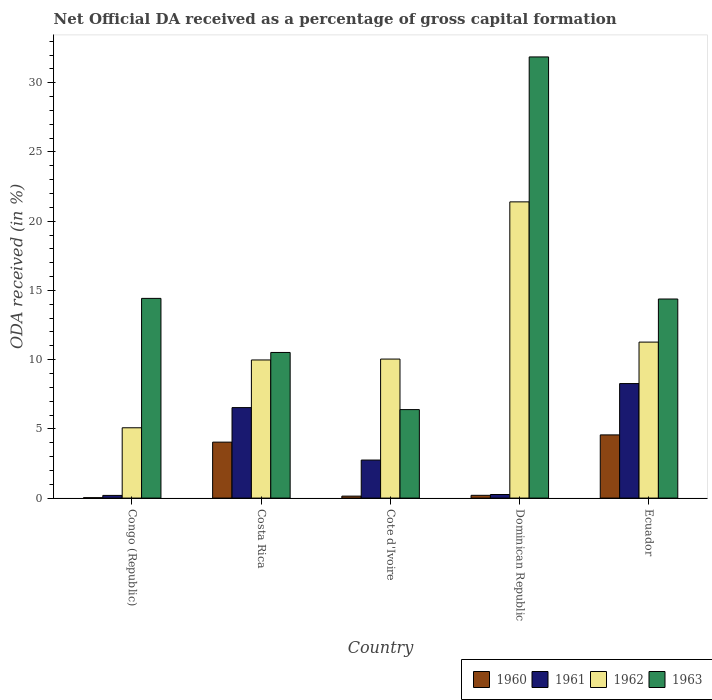How many different coloured bars are there?
Your answer should be compact. 4. How many groups of bars are there?
Your answer should be very brief. 5. How many bars are there on the 1st tick from the left?
Keep it short and to the point. 4. How many bars are there on the 3rd tick from the right?
Provide a short and direct response. 4. What is the label of the 3rd group of bars from the left?
Provide a short and direct response. Cote d'Ivoire. What is the net ODA received in 1962 in Dominican Republic?
Ensure brevity in your answer.  21.4. Across all countries, what is the maximum net ODA received in 1960?
Provide a short and direct response. 4.56. Across all countries, what is the minimum net ODA received in 1962?
Offer a very short reply. 5.08. In which country was the net ODA received in 1961 maximum?
Ensure brevity in your answer.  Ecuador. In which country was the net ODA received in 1960 minimum?
Your response must be concise. Congo (Republic). What is the total net ODA received in 1961 in the graph?
Keep it short and to the point. 18.01. What is the difference between the net ODA received in 1962 in Congo (Republic) and that in Ecuador?
Provide a short and direct response. -6.19. What is the difference between the net ODA received in 1963 in Costa Rica and the net ODA received in 1961 in Ecuador?
Provide a succinct answer. 2.25. What is the average net ODA received in 1961 per country?
Provide a succinct answer. 3.6. What is the difference between the net ODA received of/in 1962 and net ODA received of/in 1961 in Congo (Republic)?
Your response must be concise. 4.89. What is the ratio of the net ODA received in 1960 in Cote d'Ivoire to that in Dominican Republic?
Your answer should be very brief. 0.71. Is the difference between the net ODA received in 1962 in Costa Rica and Ecuador greater than the difference between the net ODA received in 1961 in Costa Rica and Ecuador?
Keep it short and to the point. Yes. What is the difference between the highest and the second highest net ODA received in 1960?
Your answer should be very brief. -4.36. What is the difference between the highest and the lowest net ODA received in 1963?
Provide a succinct answer. 25.47. Is the sum of the net ODA received in 1963 in Congo (Republic) and Ecuador greater than the maximum net ODA received in 1960 across all countries?
Give a very brief answer. Yes. Is it the case that in every country, the sum of the net ODA received in 1961 and net ODA received in 1962 is greater than the sum of net ODA received in 1963 and net ODA received in 1960?
Offer a terse response. No. What does the 2nd bar from the left in Ecuador represents?
Give a very brief answer. 1961. What does the 1st bar from the right in Costa Rica represents?
Give a very brief answer. 1963. Are all the bars in the graph horizontal?
Your answer should be very brief. No. What is the difference between two consecutive major ticks on the Y-axis?
Keep it short and to the point. 5. Does the graph contain any zero values?
Your response must be concise. No. How are the legend labels stacked?
Keep it short and to the point. Horizontal. What is the title of the graph?
Your response must be concise. Net Official DA received as a percentage of gross capital formation. Does "2014" appear as one of the legend labels in the graph?
Provide a short and direct response. No. What is the label or title of the Y-axis?
Ensure brevity in your answer.  ODA received (in %). What is the ODA received (in %) in 1960 in Congo (Republic)?
Keep it short and to the point. 0.03. What is the ODA received (in %) of 1961 in Congo (Republic)?
Give a very brief answer. 0.19. What is the ODA received (in %) of 1962 in Congo (Republic)?
Give a very brief answer. 5.08. What is the ODA received (in %) of 1963 in Congo (Republic)?
Make the answer very short. 14.43. What is the ODA received (in %) of 1960 in Costa Rica?
Make the answer very short. 4.04. What is the ODA received (in %) of 1961 in Costa Rica?
Keep it short and to the point. 6.54. What is the ODA received (in %) in 1962 in Costa Rica?
Your response must be concise. 9.98. What is the ODA received (in %) in 1963 in Costa Rica?
Keep it short and to the point. 10.52. What is the ODA received (in %) in 1960 in Cote d'Ivoire?
Offer a terse response. 0.14. What is the ODA received (in %) in 1961 in Cote d'Ivoire?
Ensure brevity in your answer.  2.75. What is the ODA received (in %) of 1962 in Cote d'Ivoire?
Your answer should be compact. 10.04. What is the ODA received (in %) of 1963 in Cote d'Ivoire?
Your answer should be compact. 6.39. What is the ODA received (in %) in 1960 in Dominican Republic?
Your answer should be very brief. 0.2. What is the ODA received (in %) in 1961 in Dominican Republic?
Give a very brief answer. 0.26. What is the ODA received (in %) of 1962 in Dominican Republic?
Give a very brief answer. 21.4. What is the ODA received (in %) of 1963 in Dominican Republic?
Your answer should be very brief. 31.86. What is the ODA received (in %) of 1960 in Ecuador?
Provide a short and direct response. 4.56. What is the ODA received (in %) in 1961 in Ecuador?
Make the answer very short. 8.27. What is the ODA received (in %) of 1962 in Ecuador?
Your answer should be compact. 11.27. What is the ODA received (in %) of 1963 in Ecuador?
Provide a succinct answer. 14.38. Across all countries, what is the maximum ODA received (in %) in 1960?
Make the answer very short. 4.56. Across all countries, what is the maximum ODA received (in %) of 1961?
Your answer should be compact. 8.27. Across all countries, what is the maximum ODA received (in %) in 1962?
Your answer should be very brief. 21.4. Across all countries, what is the maximum ODA received (in %) in 1963?
Your answer should be compact. 31.86. Across all countries, what is the minimum ODA received (in %) in 1960?
Your response must be concise. 0.03. Across all countries, what is the minimum ODA received (in %) of 1961?
Your answer should be very brief. 0.19. Across all countries, what is the minimum ODA received (in %) of 1962?
Make the answer very short. 5.08. Across all countries, what is the minimum ODA received (in %) in 1963?
Your answer should be very brief. 6.39. What is the total ODA received (in %) in 1960 in the graph?
Your answer should be compact. 8.98. What is the total ODA received (in %) in 1961 in the graph?
Provide a succinct answer. 18.01. What is the total ODA received (in %) of 1962 in the graph?
Your response must be concise. 57.76. What is the total ODA received (in %) in 1963 in the graph?
Provide a succinct answer. 77.58. What is the difference between the ODA received (in %) in 1960 in Congo (Republic) and that in Costa Rica?
Your answer should be very brief. -4.01. What is the difference between the ODA received (in %) in 1961 in Congo (Republic) and that in Costa Rica?
Make the answer very short. -6.34. What is the difference between the ODA received (in %) in 1962 in Congo (Republic) and that in Costa Rica?
Your answer should be compact. -4.9. What is the difference between the ODA received (in %) in 1963 in Congo (Republic) and that in Costa Rica?
Provide a succinct answer. 3.91. What is the difference between the ODA received (in %) of 1960 in Congo (Republic) and that in Cote d'Ivoire?
Give a very brief answer. -0.11. What is the difference between the ODA received (in %) of 1961 in Congo (Republic) and that in Cote d'Ivoire?
Ensure brevity in your answer.  -2.55. What is the difference between the ODA received (in %) in 1962 in Congo (Republic) and that in Cote d'Ivoire?
Your answer should be very brief. -4.96. What is the difference between the ODA received (in %) of 1963 in Congo (Republic) and that in Cote d'Ivoire?
Provide a short and direct response. 8.03. What is the difference between the ODA received (in %) of 1960 in Congo (Republic) and that in Dominican Republic?
Your answer should be very brief. -0.17. What is the difference between the ODA received (in %) in 1961 in Congo (Republic) and that in Dominican Republic?
Provide a short and direct response. -0.06. What is the difference between the ODA received (in %) in 1962 in Congo (Republic) and that in Dominican Republic?
Offer a very short reply. -16.32. What is the difference between the ODA received (in %) of 1963 in Congo (Republic) and that in Dominican Republic?
Make the answer very short. -17.44. What is the difference between the ODA received (in %) of 1960 in Congo (Republic) and that in Ecuador?
Your answer should be very brief. -4.54. What is the difference between the ODA received (in %) in 1961 in Congo (Republic) and that in Ecuador?
Keep it short and to the point. -8.08. What is the difference between the ODA received (in %) of 1962 in Congo (Republic) and that in Ecuador?
Your answer should be very brief. -6.19. What is the difference between the ODA received (in %) in 1963 in Congo (Republic) and that in Ecuador?
Give a very brief answer. 0.05. What is the difference between the ODA received (in %) in 1960 in Costa Rica and that in Cote d'Ivoire?
Your answer should be compact. 3.9. What is the difference between the ODA received (in %) of 1961 in Costa Rica and that in Cote d'Ivoire?
Make the answer very short. 3.79. What is the difference between the ODA received (in %) in 1962 in Costa Rica and that in Cote d'Ivoire?
Give a very brief answer. -0.06. What is the difference between the ODA received (in %) in 1963 in Costa Rica and that in Cote d'Ivoire?
Your answer should be very brief. 4.13. What is the difference between the ODA received (in %) of 1960 in Costa Rica and that in Dominican Republic?
Keep it short and to the point. 3.84. What is the difference between the ODA received (in %) in 1961 in Costa Rica and that in Dominican Republic?
Offer a very short reply. 6.28. What is the difference between the ODA received (in %) in 1962 in Costa Rica and that in Dominican Republic?
Your response must be concise. -11.42. What is the difference between the ODA received (in %) of 1963 in Costa Rica and that in Dominican Republic?
Offer a very short reply. -21.35. What is the difference between the ODA received (in %) of 1960 in Costa Rica and that in Ecuador?
Make the answer very short. -0.52. What is the difference between the ODA received (in %) of 1961 in Costa Rica and that in Ecuador?
Offer a very short reply. -1.74. What is the difference between the ODA received (in %) of 1962 in Costa Rica and that in Ecuador?
Give a very brief answer. -1.29. What is the difference between the ODA received (in %) of 1963 in Costa Rica and that in Ecuador?
Provide a succinct answer. -3.86. What is the difference between the ODA received (in %) of 1960 in Cote d'Ivoire and that in Dominican Republic?
Your answer should be very brief. -0.06. What is the difference between the ODA received (in %) in 1961 in Cote d'Ivoire and that in Dominican Republic?
Your answer should be very brief. 2.49. What is the difference between the ODA received (in %) in 1962 in Cote d'Ivoire and that in Dominican Republic?
Offer a very short reply. -11.35. What is the difference between the ODA received (in %) of 1963 in Cote d'Ivoire and that in Dominican Republic?
Your answer should be very brief. -25.47. What is the difference between the ODA received (in %) of 1960 in Cote d'Ivoire and that in Ecuador?
Offer a terse response. -4.42. What is the difference between the ODA received (in %) in 1961 in Cote d'Ivoire and that in Ecuador?
Ensure brevity in your answer.  -5.52. What is the difference between the ODA received (in %) of 1962 in Cote d'Ivoire and that in Ecuador?
Give a very brief answer. -1.23. What is the difference between the ODA received (in %) of 1963 in Cote d'Ivoire and that in Ecuador?
Offer a very short reply. -7.99. What is the difference between the ODA received (in %) in 1960 in Dominican Republic and that in Ecuador?
Your answer should be very brief. -4.36. What is the difference between the ODA received (in %) of 1961 in Dominican Republic and that in Ecuador?
Give a very brief answer. -8.01. What is the difference between the ODA received (in %) in 1962 in Dominican Republic and that in Ecuador?
Give a very brief answer. 10.13. What is the difference between the ODA received (in %) in 1963 in Dominican Republic and that in Ecuador?
Provide a short and direct response. 17.49. What is the difference between the ODA received (in %) in 1960 in Congo (Republic) and the ODA received (in %) in 1961 in Costa Rica?
Your answer should be very brief. -6.51. What is the difference between the ODA received (in %) of 1960 in Congo (Republic) and the ODA received (in %) of 1962 in Costa Rica?
Make the answer very short. -9.95. What is the difference between the ODA received (in %) in 1960 in Congo (Republic) and the ODA received (in %) in 1963 in Costa Rica?
Provide a short and direct response. -10.49. What is the difference between the ODA received (in %) in 1961 in Congo (Republic) and the ODA received (in %) in 1962 in Costa Rica?
Give a very brief answer. -9.78. What is the difference between the ODA received (in %) in 1961 in Congo (Republic) and the ODA received (in %) in 1963 in Costa Rica?
Offer a very short reply. -10.32. What is the difference between the ODA received (in %) of 1962 in Congo (Republic) and the ODA received (in %) of 1963 in Costa Rica?
Keep it short and to the point. -5.44. What is the difference between the ODA received (in %) of 1960 in Congo (Republic) and the ODA received (in %) of 1961 in Cote d'Ivoire?
Your response must be concise. -2.72. What is the difference between the ODA received (in %) of 1960 in Congo (Republic) and the ODA received (in %) of 1962 in Cote d'Ivoire?
Give a very brief answer. -10.01. What is the difference between the ODA received (in %) of 1960 in Congo (Republic) and the ODA received (in %) of 1963 in Cote d'Ivoire?
Provide a short and direct response. -6.36. What is the difference between the ODA received (in %) in 1961 in Congo (Republic) and the ODA received (in %) in 1962 in Cote d'Ivoire?
Keep it short and to the point. -9.85. What is the difference between the ODA received (in %) in 1961 in Congo (Republic) and the ODA received (in %) in 1963 in Cote d'Ivoire?
Provide a succinct answer. -6.2. What is the difference between the ODA received (in %) in 1962 in Congo (Republic) and the ODA received (in %) in 1963 in Cote d'Ivoire?
Keep it short and to the point. -1.31. What is the difference between the ODA received (in %) of 1960 in Congo (Republic) and the ODA received (in %) of 1961 in Dominican Republic?
Ensure brevity in your answer.  -0.23. What is the difference between the ODA received (in %) of 1960 in Congo (Republic) and the ODA received (in %) of 1962 in Dominican Republic?
Give a very brief answer. -21.37. What is the difference between the ODA received (in %) of 1960 in Congo (Republic) and the ODA received (in %) of 1963 in Dominican Republic?
Make the answer very short. -31.84. What is the difference between the ODA received (in %) in 1961 in Congo (Republic) and the ODA received (in %) in 1962 in Dominican Republic?
Give a very brief answer. -21.2. What is the difference between the ODA received (in %) of 1961 in Congo (Republic) and the ODA received (in %) of 1963 in Dominican Republic?
Your response must be concise. -31.67. What is the difference between the ODA received (in %) of 1962 in Congo (Republic) and the ODA received (in %) of 1963 in Dominican Republic?
Offer a very short reply. -26.79. What is the difference between the ODA received (in %) of 1960 in Congo (Republic) and the ODA received (in %) of 1961 in Ecuador?
Your response must be concise. -8.24. What is the difference between the ODA received (in %) of 1960 in Congo (Republic) and the ODA received (in %) of 1962 in Ecuador?
Ensure brevity in your answer.  -11.24. What is the difference between the ODA received (in %) in 1960 in Congo (Republic) and the ODA received (in %) in 1963 in Ecuador?
Offer a very short reply. -14.35. What is the difference between the ODA received (in %) of 1961 in Congo (Republic) and the ODA received (in %) of 1962 in Ecuador?
Your answer should be compact. -11.07. What is the difference between the ODA received (in %) in 1961 in Congo (Republic) and the ODA received (in %) in 1963 in Ecuador?
Your answer should be compact. -14.19. What is the difference between the ODA received (in %) in 1962 in Congo (Republic) and the ODA received (in %) in 1963 in Ecuador?
Give a very brief answer. -9.3. What is the difference between the ODA received (in %) of 1960 in Costa Rica and the ODA received (in %) of 1961 in Cote d'Ivoire?
Make the answer very short. 1.29. What is the difference between the ODA received (in %) of 1960 in Costa Rica and the ODA received (in %) of 1962 in Cote d'Ivoire?
Provide a succinct answer. -6. What is the difference between the ODA received (in %) in 1960 in Costa Rica and the ODA received (in %) in 1963 in Cote d'Ivoire?
Provide a succinct answer. -2.35. What is the difference between the ODA received (in %) in 1961 in Costa Rica and the ODA received (in %) in 1962 in Cote d'Ivoire?
Ensure brevity in your answer.  -3.51. What is the difference between the ODA received (in %) in 1961 in Costa Rica and the ODA received (in %) in 1963 in Cote d'Ivoire?
Ensure brevity in your answer.  0.14. What is the difference between the ODA received (in %) of 1962 in Costa Rica and the ODA received (in %) of 1963 in Cote d'Ivoire?
Your answer should be compact. 3.59. What is the difference between the ODA received (in %) in 1960 in Costa Rica and the ODA received (in %) in 1961 in Dominican Republic?
Offer a very short reply. 3.78. What is the difference between the ODA received (in %) in 1960 in Costa Rica and the ODA received (in %) in 1962 in Dominican Republic?
Your response must be concise. -17.35. What is the difference between the ODA received (in %) of 1960 in Costa Rica and the ODA received (in %) of 1963 in Dominican Republic?
Provide a short and direct response. -27.82. What is the difference between the ODA received (in %) of 1961 in Costa Rica and the ODA received (in %) of 1962 in Dominican Republic?
Offer a very short reply. -14.86. What is the difference between the ODA received (in %) of 1961 in Costa Rica and the ODA received (in %) of 1963 in Dominican Republic?
Your response must be concise. -25.33. What is the difference between the ODA received (in %) in 1962 in Costa Rica and the ODA received (in %) in 1963 in Dominican Republic?
Your response must be concise. -21.89. What is the difference between the ODA received (in %) in 1960 in Costa Rica and the ODA received (in %) in 1961 in Ecuador?
Your response must be concise. -4.23. What is the difference between the ODA received (in %) in 1960 in Costa Rica and the ODA received (in %) in 1962 in Ecuador?
Your answer should be compact. -7.23. What is the difference between the ODA received (in %) of 1960 in Costa Rica and the ODA received (in %) of 1963 in Ecuador?
Offer a very short reply. -10.34. What is the difference between the ODA received (in %) of 1961 in Costa Rica and the ODA received (in %) of 1962 in Ecuador?
Offer a very short reply. -4.73. What is the difference between the ODA received (in %) in 1961 in Costa Rica and the ODA received (in %) in 1963 in Ecuador?
Your answer should be very brief. -7.84. What is the difference between the ODA received (in %) of 1962 in Costa Rica and the ODA received (in %) of 1963 in Ecuador?
Provide a succinct answer. -4.4. What is the difference between the ODA received (in %) of 1960 in Cote d'Ivoire and the ODA received (in %) of 1961 in Dominican Republic?
Offer a very short reply. -0.12. What is the difference between the ODA received (in %) in 1960 in Cote d'Ivoire and the ODA received (in %) in 1962 in Dominican Republic?
Your answer should be very brief. -21.25. What is the difference between the ODA received (in %) of 1960 in Cote d'Ivoire and the ODA received (in %) of 1963 in Dominican Republic?
Offer a terse response. -31.72. What is the difference between the ODA received (in %) of 1961 in Cote d'Ivoire and the ODA received (in %) of 1962 in Dominican Republic?
Provide a succinct answer. -18.65. What is the difference between the ODA received (in %) in 1961 in Cote d'Ivoire and the ODA received (in %) in 1963 in Dominican Republic?
Keep it short and to the point. -29.12. What is the difference between the ODA received (in %) of 1962 in Cote d'Ivoire and the ODA received (in %) of 1963 in Dominican Republic?
Your answer should be very brief. -21.82. What is the difference between the ODA received (in %) of 1960 in Cote d'Ivoire and the ODA received (in %) of 1961 in Ecuador?
Give a very brief answer. -8.13. What is the difference between the ODA received (in %) in 1960 in Cote d'Ivoire and the ODA received (in %) in 1962 in Ecuador?
Offer a very short reply. -11.12. What is the difference between the ODA received (in %) in 1960 in Cote d'Ivoire and the ODA received (in %) in 1963 in Ecuador?
Your response must be concise. -14.24. What is the difference between the ODA received (in %) in 1961 in Cote d'Ivoire and the ODA received (in %) in 1962 in Ecuador?
Ensure brevity in your answer.  -8.52. What is the difference between the ODA received (in %) in 1961 in Cote d'Ivoire and the ODA received (in %) in 1963 in Ecuador?
Make the answer very short. -11.63. What is the difference between the ODA received (in %) in 1962 in Cote d'Ivoire and the ODA received (in %) in 1963 in Ecuador?
Your answer should be very brief. -4.34. What is the difference between the ODA received (in %) of 1960 in Dominican Republic and the ODA received (in %) of 1961 in Ecuador?
Offer a very short reply. -8.07. What is the difference between the ODA received (in %) in 1960 in Dominican Republic and the ODA received (in %) in 1962 in Ecuador?
Your response must be concise. -11.07. What is the difference between the ODA received (in %) in 1960 in Dominican Republic and the ODA received (in %) in 1963 in Ecuador?
Your answer should be compact. -14.18. What is the difference between the ODA received (in %) of 1961 in Dominican Republic and the ODA received (in %) of 1962 in Ecuador?
Keep it short and to the point. -11.01. What is the difference between the ODA received (in %) in 1961 in Dominican Republic and the ODA received (in %) in 1963 in Ecuador?
Offer a terse response. -14.12. What is the difference between the ODA received (in %) in 1962 in Dominican Republic and the ODA received (in %) in 1963 in Ecuador?
Your answer should be compact. 7.02. What is the average ODA received (in %) of 1960 per country?
Give a very brief answer. 1.8. What is the average ODA received (in %) in 1961 per country?
Provide a short and direct response. 3.6. What is the average ODA received (in %) in 1962 per country?
Offer a very short reply. 11.55. What is the average ODA received (in %) in 1963 per country?
Offer a terse response. 15.52. What is the difference between the ODA received (in %) of 1960 and ODA received (in %) of 1961 in Congo (Republic)?
Provide a succinct answer. -0.17. What is the difference between the ODA received (in %) in 1960 and ODA received (in %) in 1962 in Congo (Republic)?
Your answer should be very brief. -5.05. What is the difference between the ODA received (in %) in 1960 and ODA received (in %) in 1963 in Congo (Republic)?
Offer a terse response. -14.4. What is the difference between the ODA received (in %) in 1961 and ODA received (in %) in 1962 in Congo (Republic)?
Give a very brief answer. -4.89. What is the difference between the ODA received (in %) of 1961 and ODA received (in %) of 1963 in Congo (Republic)?
Give a very brief answer. -14.23. What is the difference between the ODA received (in %) in 1962 and ODA received (in %) in 1963 in Congo (Republic)?
Your response must be concise. -9.35. What is the difference between the ODA received (in %) of 1960 and ODA received (in %) of 1961 in Costa Rica?
Ensure brevity in your answer.  -2.49. What is the difference between the ODA received (in %) in 1960 and ODA received (in %) in 1962 in Costa Rica?
Make the answer very short. -5.93. What is the difference between the ODA received (in %) in 1960 and ODA received (in %) in 1963 in Costa Rica?
Your response must be concise. -6.48. What is the difference between the ODA received (in %) in 1961 and ODA received (in %) in 1962 in Costa Rica?
Offer a very short reply. -3.44. What is the difference between the ODA received (in %) in 1961 and ODA received (in %) in 1963 in Costa Rica?
Ensure brevity in your answer.  -3.98. What is the difference between the ODA received (in %) in 1962 and ODA received (in %) in 1963 in Costa Rica?
Offer a very short reply. -0.54. What is the difference between the ODA received (in %) of 1960 and ODA received (in %) of 1961 in Cote d'Ivoire?
Make the answer very short. -2.6. What is the difference between the ODA received (in %) in 1960 and ODA received (in %) in 1962 in Cote d'Ivoire?
Provide a short and direct response. -9.9. What is the difference between the ODA received (in %) of 1960 and ODA received (in %) of 1963 in Cote d'Ivoire?
Give a very brief answer. -6.25. What is the difference between the ODA received (in %) in 1961 and ODA received (in %) in 1962 in Cote d'Ivoire?
Provide a succinct answer. -7.29. What is the difference between the ODA received (in %) of 1961 and ODA received (in %) of 1963 in Cote d'Ivoire?
Give a very brief answer. -3.64. What is the difference between the ODA received (in %) of 1962 and ODA received (in %) of 1963 in Cote d'Ivoire?
Your answer should be compact. 3.65. What is the difference between the ODA received (in %) in 1960 and ODA received (in %) in 1961 in Dominican Republic?
Your answer should be very brief. -0.06. What is the difference between the ODA received (in %) of 1960 and ODA received (in %) of 1962 in Dominican Republic?
Your answer should be very brief. -21.2. What is the difference between the ODA received (in %) of 1960 and ODA received (in %) of 1963 in Dominican Republic?
Ensure brevity in your answer.  -31.66. What is the difference between the ODA received (in %) in 1961 and ODA received (in %) in 1962 in Dominican Republic?
Your response must be concise. -21.14. What is the difference between the ODA received (in %) of 1961 and ODA received (in %) of 1963 in Dominican Republic?
Your answer should be compact. -31.61. What is the difference between the ODA received (in %) of 1962 and ODA received (in %) of 1963 in Dominican Republic?
Provide a succinct answer. -10.47. What is the difference between the ODA received (in %) in 1960 and ODA received (in %) in 1961 in Ecuador?
Your answer should be compact. -3.71. What is the difference between the ODA received (in %) in 1960 and ODA received (in %) in 1962 in Ecuador?
Your answer should be compact. -6.7. What is the difference between the ODA received (in %) in 1960 and ODA received (in %) in 1963 in Ecuador?
Provide a short and direct response. -9.81. What is the difference between the ODA received (in %) of 1961 and ODA received (in %) of 1962 in Ecuador?
Give a very brief answer. -3. What is the difference between the ODA received (in %) in 1961 and ODA received (in %) in 1963 in Ecuador?
Provide a short and direct response. -6.11. What is the difference between the ODA received (in %) of 1962 and ODA received (in %) of 1963 in Ecuador?
Provide a succinct answer. -3.11. What is the ratio of the ODA received (in %) of 1960 in Congo (Republic) to that in Costa Rica?
Your answer should be compact. 0.01. What is the ratio of the ODA received (in %) in 1961 in Congo (Republic) to that in Costa Rica?
Ensure brevity in your answer.  0.03. What is the ratio of the ODA received (in %) of 1962 in Congo (Republic) to that in Costa Rica?
Make the answer very short. 0.51. What is the ratio of the ODA received (in %) of 1963 in Congo (Republic) to that in Costa Rica?
Make the answer very short. 1.37. What is the ratio of the ODA received (in %) in 1960 in Congo (Republic) to that in Cote d'Ivoire?
Your response must be concise. 0.2. What is the ratio of the ODA received (in %) in 1961 in Congo (Republic) to that in Cote d'Ivoire?
Provide a short and direct response. 0.07. What is the ratio of the ODA received (in %) in 1962 in Congo (Republic) to that in Cote d'Ivoire?
Your answer should be compact. 0.51. What is the ratio of the ODA received (in %) of 1963 in Congo (Republic) to that in Cote d'Ivoire?
Your answer should be compact. 2.26. What is the ratio of the ODA received (in %) of 1960 in Congo (Republic) to that in Dominican Republic?
Your response must be concise. 0.14. What is the ratio of the ODA received (in %) of 1961 in Congo (Republic) to that in Dominican Republic?
Make the answer very short. 0.75. What is the ratio of the ODA received (in %) in 1962 in Congo (Republic) to that in Dominican Republic?
Give a very brief answer. 0.24. What is the ratio of the ODA received (in %) of 1963 in Congo (Republic) to that in Dominican Republic?
Give a very brief answer. 0.45. What is the ratio of the ODA received (in %) in 1960 in Congo (Republic) to that in Ecuador?
Offer a very short reply. 0.01. What is the ratio of the ODA received (in %) in 1961 in Congo (Republic) to that in Ecuador?
Give a very brief answer. 0.02. What is the ratio of the ODA received (in %) of 1962 in Congo (Republic) to that in Ecuador?
Keep it short and to the point. 0.45. What is the ratio of the ODA received (in %) of 1963 in Congo (Republic) to that in Ecuador?
Give a very brief answer. 1. What is the ratio of the ODA received (in %) in 1960 in Costa Rica to that in Cote d'Ivoire?
Keep it short and to the point. 28.4. What is the ratio of the ODA received (in %) of 1961 in Costa Rica to that in Cote d'Ivoire?
Your answer should be compact. 2.38. What is the ratio of the ODA received (in %) in 1963 in Costa Rica to that in Cote d'Ivoire?
Offer a very short reply. 1.65. What is the ratio of the ODA received (in %) in 1960 in Costa Rica to that in Dominican Republic?
Make the answer very short. 20.16. What is the ratio of the ODA received (in %) in 1961 in Costa Rica to that in Dominican Republic?
Ensure brevity in your answer.  25.27. What is the ratio of the ODA received (in %) in 1962 in Costa Rica to that in Dominican Republic?
Offer a terse response. 0.47. What is the ratio of the ODA received (in %) of 1963 in Costa Rica to that in Dominican Republic?
Give a very brief answer. 0.33. What is the ratio of the ODA received (in %) of 1960 in Costa Rica to that in Ecuador?
Offer a very short reply. 0.89. What is the ratio of the ODA received (in %) of 1961 in Costa Rica to that in Ecuador?
Your answer should be compact. 0.79. What is the ratio of the ODA received (in %) in 1962 in Costa Rica to that in Ecuador?
Your answer should be very brief. 0.89. What is the ratio of the ODA received (in %) of 1963 in Costa Rica to that in Ecuador?
Make the answer very short. 0.73. What is the ratio of the ODA received (in %) in 1960 in Cote d'Ivoire to that in Dominican Republic?
Offer a very short reply. 0.71. What is the ratio of the ODA received (in %) of 1961 in Cote d'Ivoire to that in Dominican Republic?
Your response must be concise. 10.62. What is the ratio of the ODA received (in %) of 1962 in Cote d'Ivoire to that in Dominican Republic?
Your answer should be very brief. 0.47. What is the ratio of the ODA received (in %) of 1963 in Cote d'Ivoire to that in Dominican Republic?
Offer a terse response. 0.2. What is the ratio of the ODA received (in %) in 1960 in Cote d'Ivoire to that in Ecuador?
Provide a succinct answer. 0.03. What is the ratio of the ODA received (in %) of 1961 in Cote d'Ivoire to that in Ecuador?
Keep it short and to the point. 0.33. What is the ratio of the ODA received (in %) of 1962 in Cote d'Ivoire to that in Ecuador?
Make the answer very short. 0.89. What is the ratio of the ODA received (in %) of 1963 in Cote d'Ivoire to that in Ecuador?
Offer a very short reply. 0.44. What is the ratio of the ODA received (in %) in 1960 in Dominican Republic to that in Ecuador?
Provide a short and direct response. 0.04. What is the ratio of the ODA received (in %) in 1961 in Dominican Republic to that in Ecuador?
Offer a very short reply. 0.03. What is the ratio of the ODA received (in %) of 1962 in Dominican Republic to that in Ecuador?
Make the answer very short. 1.9. What is the ratio of the ODA received (in %) in 1963 in Dominican Republic to that in Ecuador?
Provide a short and direct response. 2.22. What is the difference between the highest and the second highest ODA received (in %) of 1960?
Ensure brevity in your answer.  0.52. What is the difference between the highest and the second highest ODA received (in %) of 1961?
Ensure brevity in your answer.  1.74. What is the difference between the highest and the second highest ODA received (in %) in 1962?
Offer a very short reply. 10.13. What is the difference between the highest and the second highest ODA received (in %) of 1963?
Your answer should be compact. 17.44. What is the difference between the highest and the lowest ODA received (in %) in 1960?
Ensure brevity in your answer.  4.54. What is the difference between the highest and the lowest ODA received (in %) in 1961?
Your response must be concise. 8.08. What is the difference between the highest and the lowest ODA received (in %) in 1962?
Offer a very short reply. 16.32. What is the difference between the highest and the lowest ODA received (in %) in 1963?
Give a very brief answer. 25.47. 